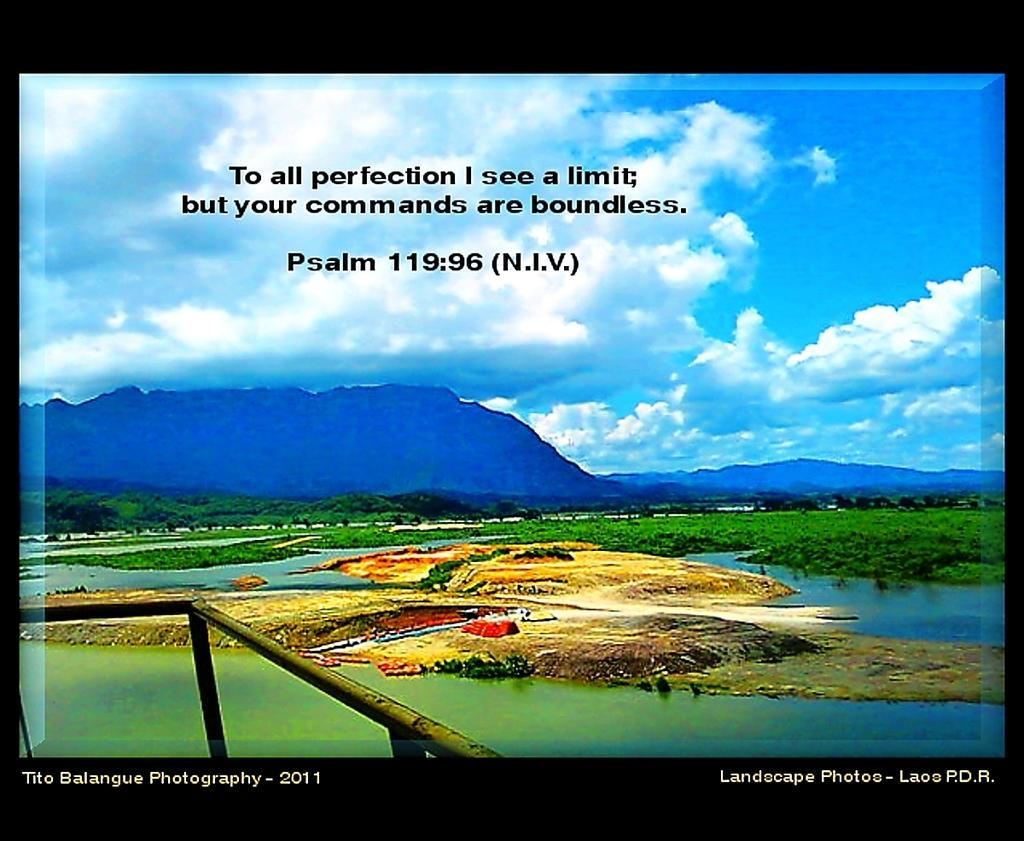<image>
Write a terse but informative summary of the picture. A landscape scene has a quote from the bible which is Psalm 119:96. 